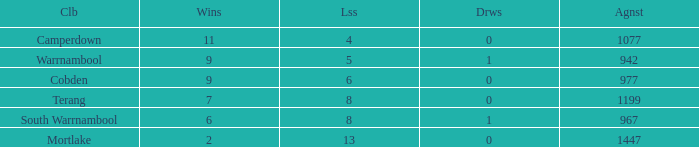What's the number of losses when the wins were more than 11 and had 0 draws? 0.0. 